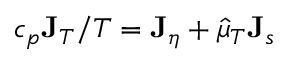Convert formula to latex. <formula><loc_0><loc_0><loc_500><loc_500>c _ { p } { J } _ { T } / T = { J } _ { \eta } + \hat { \mu } _ { T } { J } _ { s }</formula> 